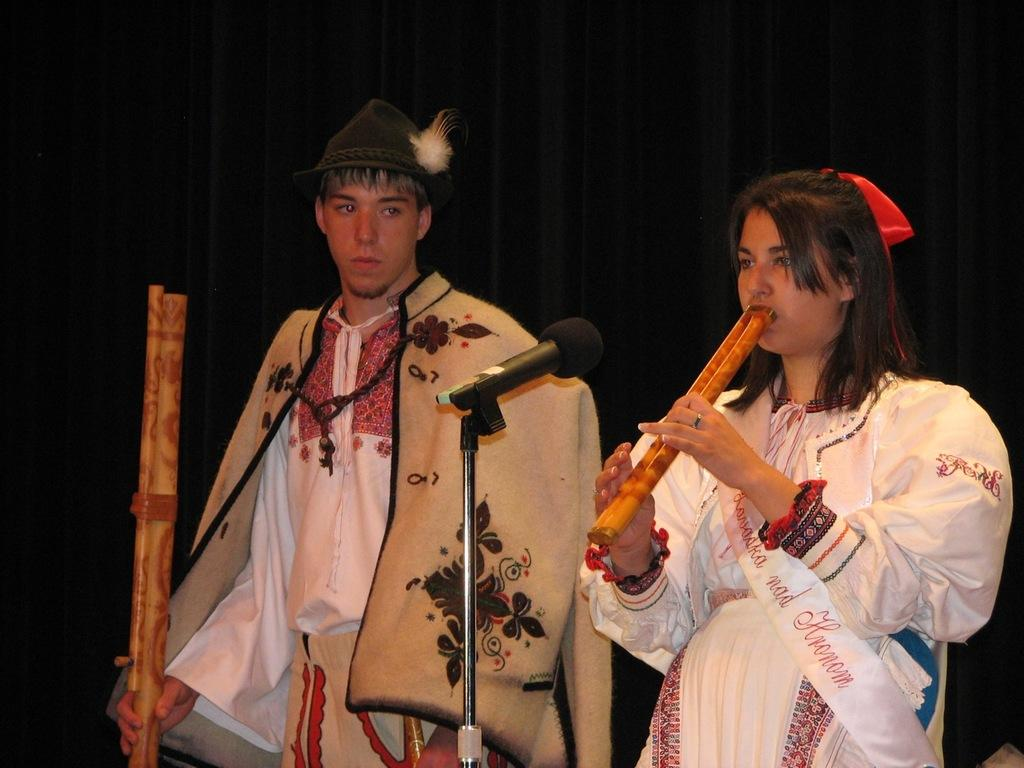How many people are in the image? There are two people in the image, a man and a woman. What are the man and the woman holding in the image? Both the man and the woman are holding bamboo musical instruments. What equipment is present for amplifying sound in the image? There is a microphone with a stand in the image. What type of backdrop can be seen in the image? There is a curtain in the image. What type of canvas is visible in the image? There is no canvas present in the image. How does the man's anger affect the woman in the image? There is no indication of anger or any emotional state in the image; both the man and the woman are holding musical instruments. 